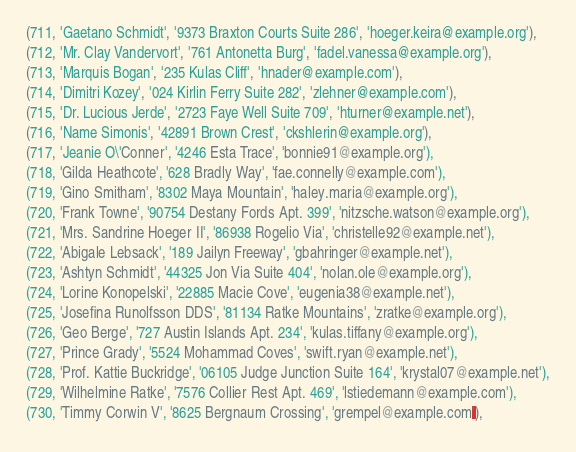<code> <loc_0><loc_0><loc_500><loc_500><_SQL_>(711, 'Gaetano Schmidt', '9373 Braxton Courts Suite 286', 'hoeger.keira@example.org'),
(712, 'Mr. Clay Vandervort', '761 Antonetta Burg', 'fadel.vanessa@example.org'),
(713, 'Marquis Bogan', '235 Kulas Cliff', 'hnader@example.com'),
(714, 'Dimitri Kozey', '024 Kirlin Ferry Suite 282', 'zlehner@example.com'),
(715, 'Dr. Lucious Jerde', '2723 Faye Well Suite 709', 'hturner@example.net'),
(716, 'Name Simonis', '42891 Brown Crest', 'ckshlerin@example.org'),
(717, 'Jeanie O\'Conner', '4246 Esta Trace', 'bonnie91@example.org'),
(718, 'Gilda Heathcote', '628 Bradly Way', 'fae.connelly@example.com'),
(719, 'Gino Smitham', '8302 Maya Mountain', 'haley.maria@example.org'),
(720, 'Frank Towne', '90754 Destany Fords Apt. 399', 'nitzsche.watson@example.org'),
(721, 'Mrs. Sandrine Hoeger II', '86938 Rogelio Via', 'christelle92@example.net'),
(722, 'Abigale Lebsack', '189 Jailyn Freeway', 'gbahringer@example.net'),
(723, 'Ashtyn Schmidt', '44325 Jon Via Suite 404', 'nolan.ole@example.org'),
(724, 'Lorine Konopelski', '22885 Macie Cove', 'eugenia38@example.net'),
(725, 'Josefina Runolfsson DDS', '81134 Ratke Mountains', 'zratke@example.org'),
(726, 'Geo Berge', '727 Austin Islands Apt. 234', 'kulas.tiffany@example.org'),
(727, 'Prince Grady', '5524 Mohammad Coves', 'swift.ryan@example.net'),
(728, 'Prof. Kattie Buckridge', '06105 Judge Junction Suite 164', 'krystal07@example.net'),
(729, 'Wilhelmine Ratke', '7576 Collier Rest Apt. 469', 'lstiedemann@example.com'),
(730, 'Timmy Corwin V', '8625 Bergnaum Crossing', 'grempel@example.com'),</code> 